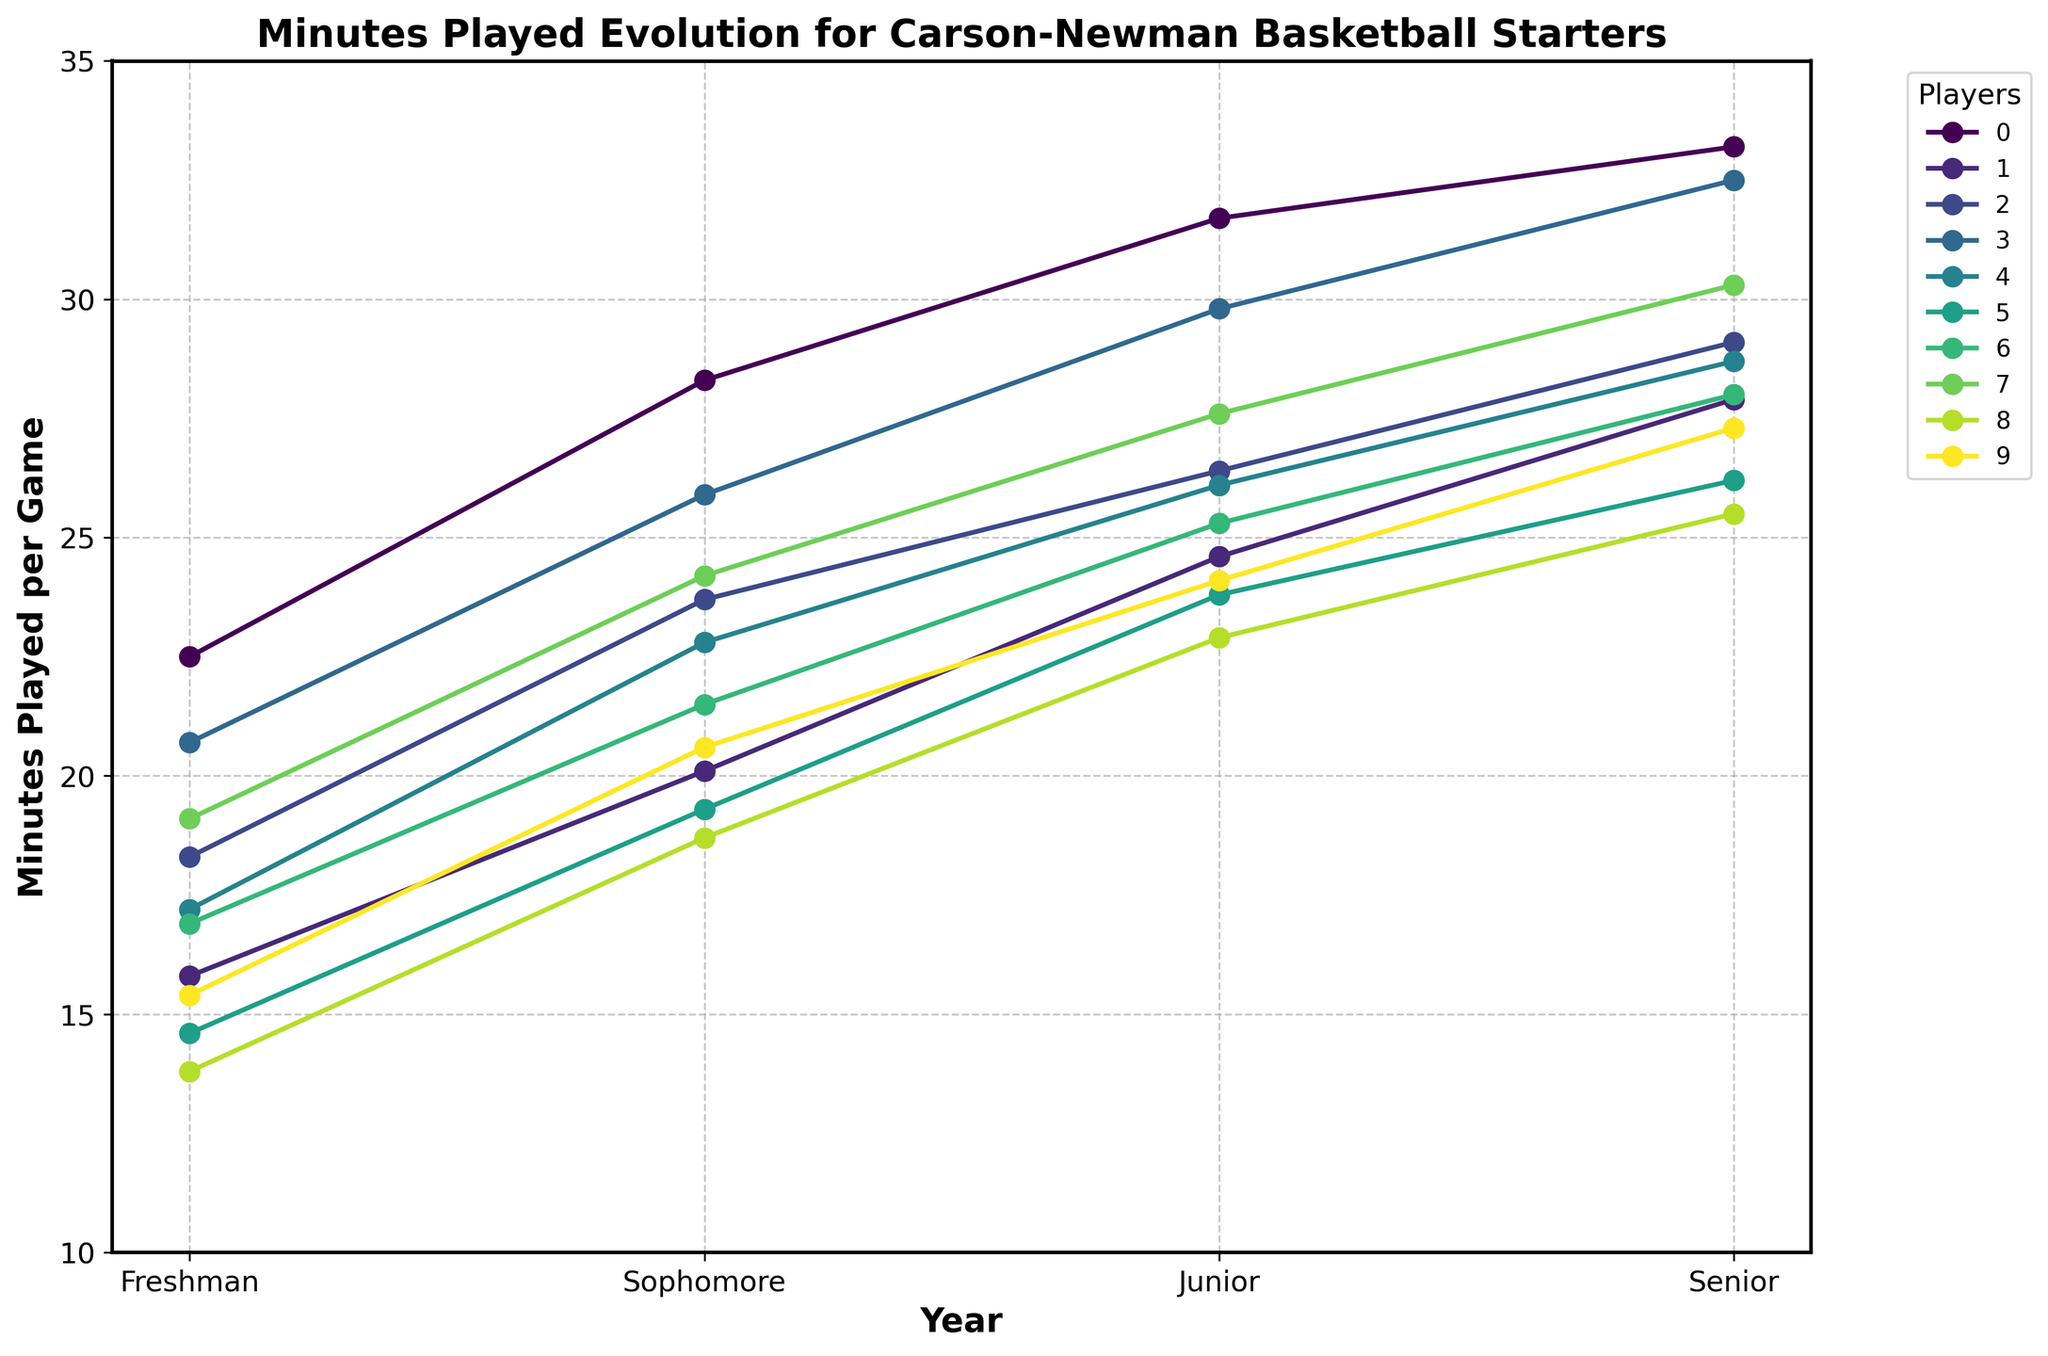What's the average minutes played per game for Charles Clark across his college career? First, sum his minutes per game: 20.7 (Freshman) + 25.9 (Sophomore) + 29.8 (Junior) + 32.5 (Senior) = 108.9. Then, divide by the number of years: 108.9 / 4 = 27.225
Answer: 27.225 Which player had the greatest increase in minutes per game from Freshman to Senior year? Calculate the difference for each player and compare. Antoine Davis: 33.2 - 22.5 = 10.7, Luke Bielawski: 27.9 - 15.8 = 12.1, Zach Pangallo: 29.1 - 18.3 = 10.8, Charles Clark: 32.5 - 20.7 = 11.8, Ish Sanders: 28.7 - 17.2 = 11.5, Sawyer Williams: 26.2 - 14.6 = 11.6, Carson Brooks: 28.0 - 16.9 = 11.1, Shaun Jones: 30.3 - 19.1 = 11.2, Reece Anderson: 25.5 - 13.8 = 11.7, Josh Rogers: 27.3 - 15.4 = 11.9. Luke Bielawski has the greatest increase of 12.1
Answer: Luke Bielawski How many players played more than 30 minutes per game in their Senior year? Observe the Senior year data points above 30 minutes. Antoine Davis: 33.2, Charles Clark: 32.5, Shaun Jones: 30.3. There are three players.
Answer: 3 Which player had the least playing time as a Freshman and what was their playing time? Check the Freshman year data points. Reece Anderson has the least playing time with 13.8 minutes per game.
Answer: Reece Anderson, 13.8 Did any player have a consistent increase in minutes each year? Look for players with rising minutes from Freshman to Senior year. Antoine Davis: 22.5, 28.3, 31.7, 33.2. Luke Bielawski: 15.8, 20.1, 24.6, 27.9. Zach Pangallo: 18.3, 23.7, 26.4, 29.1. Charles Clark: 20.7, 25.9, 29.8, 32.5. Ish Sanders: 17.2, 22.8, 26.1, 28.7. Sawyer Williams: 14.6, 19.3, 23.8, 26.2. Carson Brooks: 16.9, 21.5, 25.3, 28.0. Shaun Jones: 19.1, 24.2, 27.6, 30.3. Reece Anderson: 13.8, 18.7, 22.9, 25.5. Josh Rogers: 15.4, 20.6, 24.1, 27.3. Every player had a consistent increase each year.
Answer: Yes What is the average minutes played by all players during their Junior year? Sum the Junior year minutes for all players: 31.7 + 24.6 + 26.4 + 29.8 + 26.1 + 23.8 + 25.3 + 27.6 + 22.9 + 24.1 = 262.3. Divide by the number of players (10): 262.3/10 = 26.23
Answer: 26.23 Which player showed the smallest improvement from Freshman to Senior year? Calculate differences for each player and compare. Antoine Davis: 33.2 - 22.5 = 10.7, Luke Bielawski: 27.9 - 15.8 = 12.1, Zach Pangallo: 29.1 - 18.3 = 10.8, Charles Clark: 32.5 - 20.7 = 11.8, Ish Sanders: 28.7 - 17.2 = 11.5, Sawyer Williams: 26.2 - 14.6 = 11.6, Carson Brooks: 28.0 - 16.9 = 11.1, Shaun Jones: 30.3 - 19.1 = 11.2, Reece Anderson: 25.5 - 13.8 = 11.7, Josh Rogers: 27.3 - 15.4 = 11.9. Antoine Davis has the smallest improvement of 10.7
Answer: Antoine Davis 